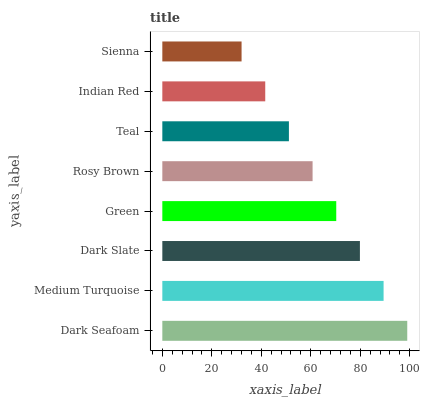Is Sienna the minimum?
Answer yes or no. Yes. Is Dark Seafoam the maximum?
Answer yes or no. Yes. Is Medium Turquoise the minimum?
Answer yes or no. No. Is Medium Turquoise the maximum?
Answer yes or no. No. Is Dark Seafoam greater than Medium Turquoise?
Answer yes or no. Yes. Is Medium Turquoise less than Dark Seafoam?
Answer yes or no. Yes. Is Medium Turquoise greater than Dark Seafoam?
Answer yes or no. No. Is Dark Seafoam less than Medium Turquoise?
Answer yes or no. No. Is Green the high median?
Answer yes or no. Yes. Is Rosy Brown the low median?
Answer yes or no. Yes. Is Dark Seafoam the high median?
Answer yes or no. No. Is Green the low median?
Answer yes or no. No. 